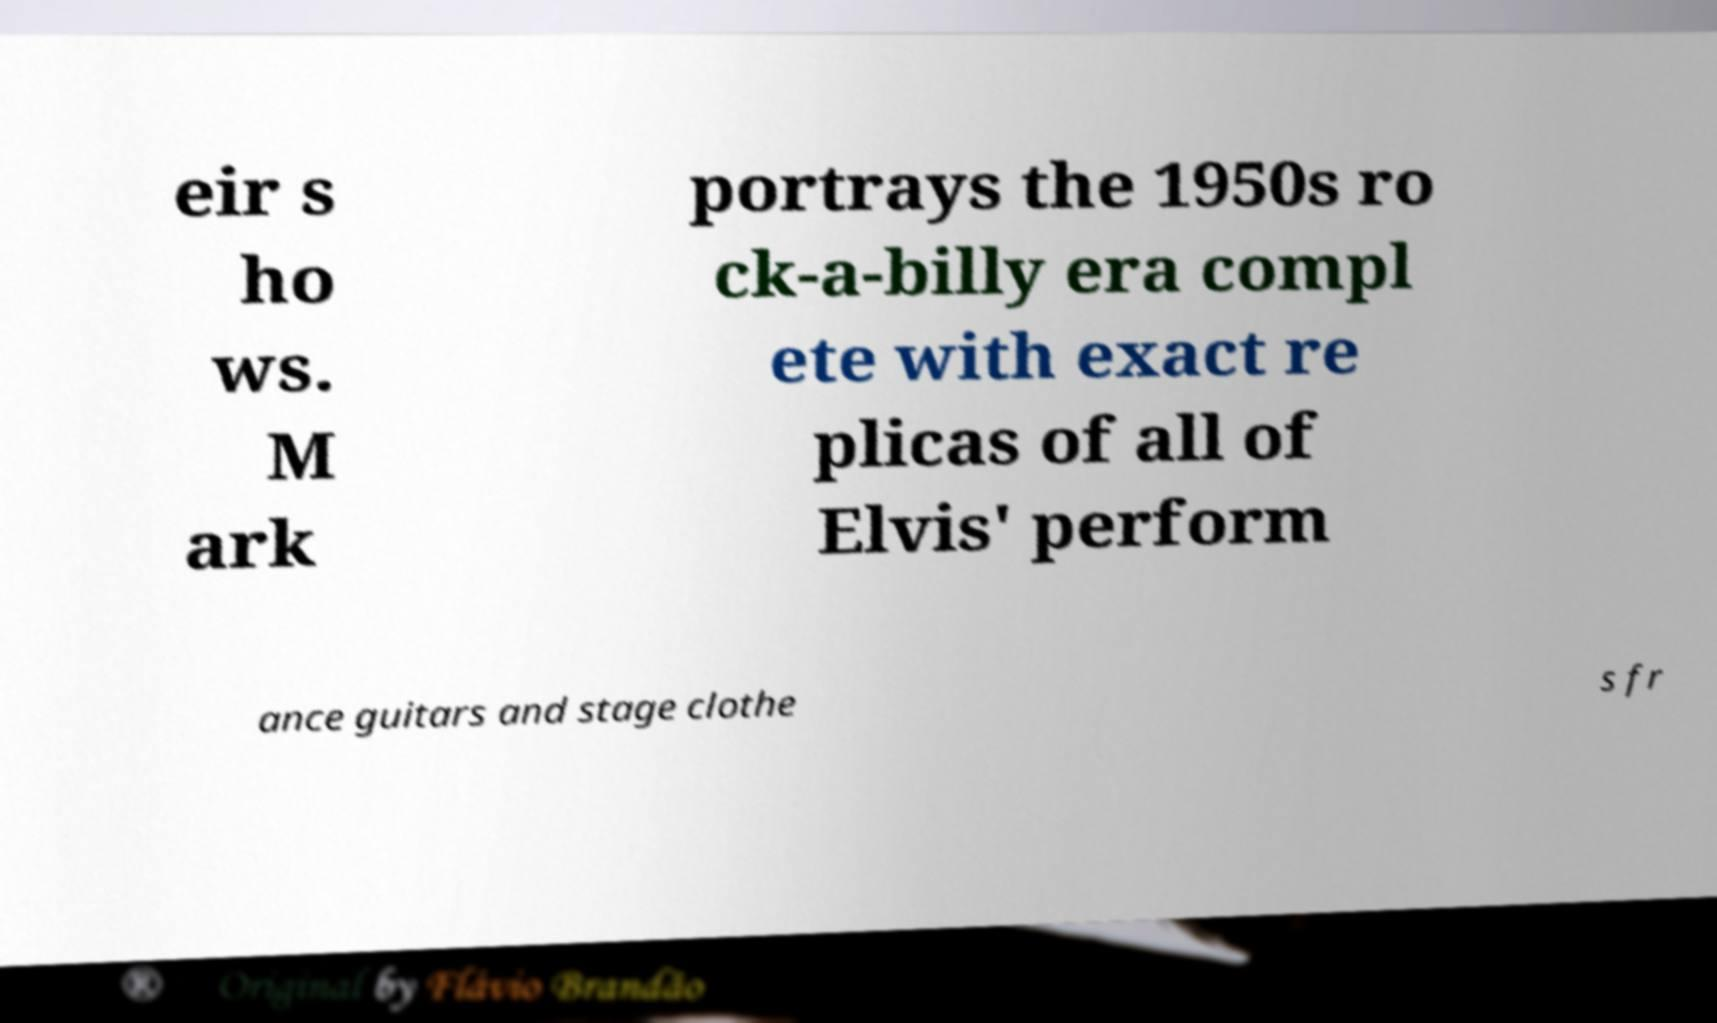Please identify and transcribe the text found in this image. eir s ho ws. M ark portrays the 1950s ro ck-a-billy era compl ete with exact re plicas of all of Elvis' perform ance guitars and stage clothe s fr 